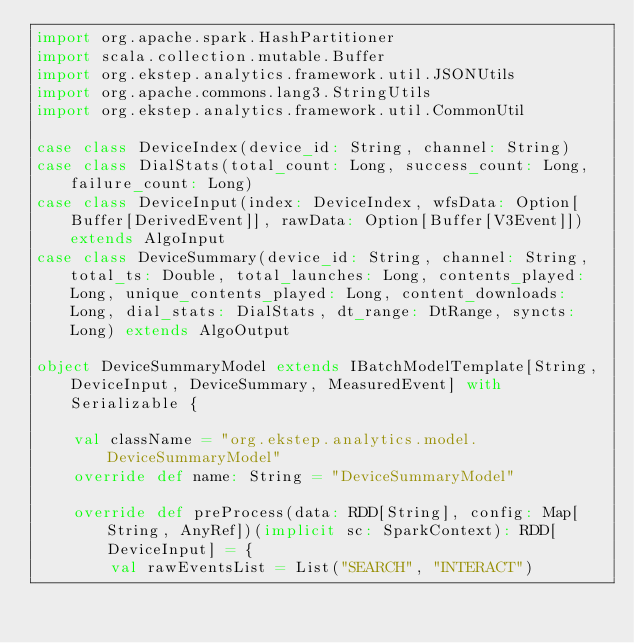<code> <loc_0><loc_0><loc_500><loc_500><_Scala_>import org.apache.spark.HashPartitioner
import scala.collection.mutable.Buffer
import org.ekstep.analytics.framework.util.JSONUtils
import org.apache.commons.lang3.StringUtils
import org.ekstep.analytics.framework.util.CommonUtil

case class DeviceIndex(device_id: String, channel: String)
case class DialStats(total_count: Long, success_count: Long, failure_count: Long)
case class DeviceInput(index: DeviceIndex, wfsData: Option[Buffer[DerivedEvent]], rawData: Option[Buffer[V3Event]]) extends AlgoInput
case class DeviceSummary(device_id: String, channel: String, total_ts: Double, total_launches: Long, contents_played: Long, unique_contents_played: Long, content_downloads: Long, dial_stats: DialStats, dt_range: DtRange, syncts: Long) extends AlgoOutput

object DeviceSummaryModel extends IBatchModelTemplate[String, DeviceInput, DeviceSummary, MeasuredEvent] with Serializable {

    val className = "org.ekstep.analytics.model.DeviceSummaryModel"
    override def name: String = "DeviceSummaryModel"

    override def preProcess(data: RDD[String], config: Map[String, AnyRef])(implicit sc: SparkContext): RDD[DeviceInput] = {
        val rawEventsList = List("SEARCH", "INTERACT")</code> 